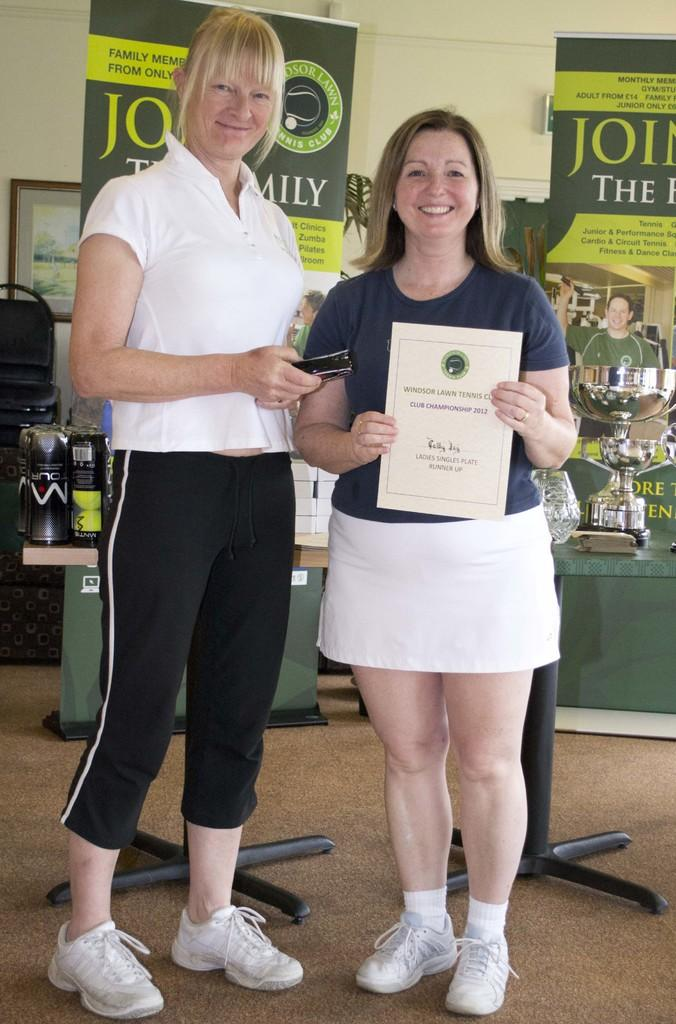Who is the main subject in the image? There is a woman standing in the center of the image. What is the woman standing on? The woman is standing on the floor. What can be seen in the background of the image? There are bottles, trophies, advertisements, and photo frames in the background of the image. What type of structure is visible in the background? There is a wall in the background of the image. How many battles has the woman won, as depicted in the image? There is no indication of any battles in the image, and the woman's achievements are not mentioned. 